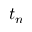<formula> <loc_0><loc_0><loc_500><loc_500>t _ { n }</formula> 